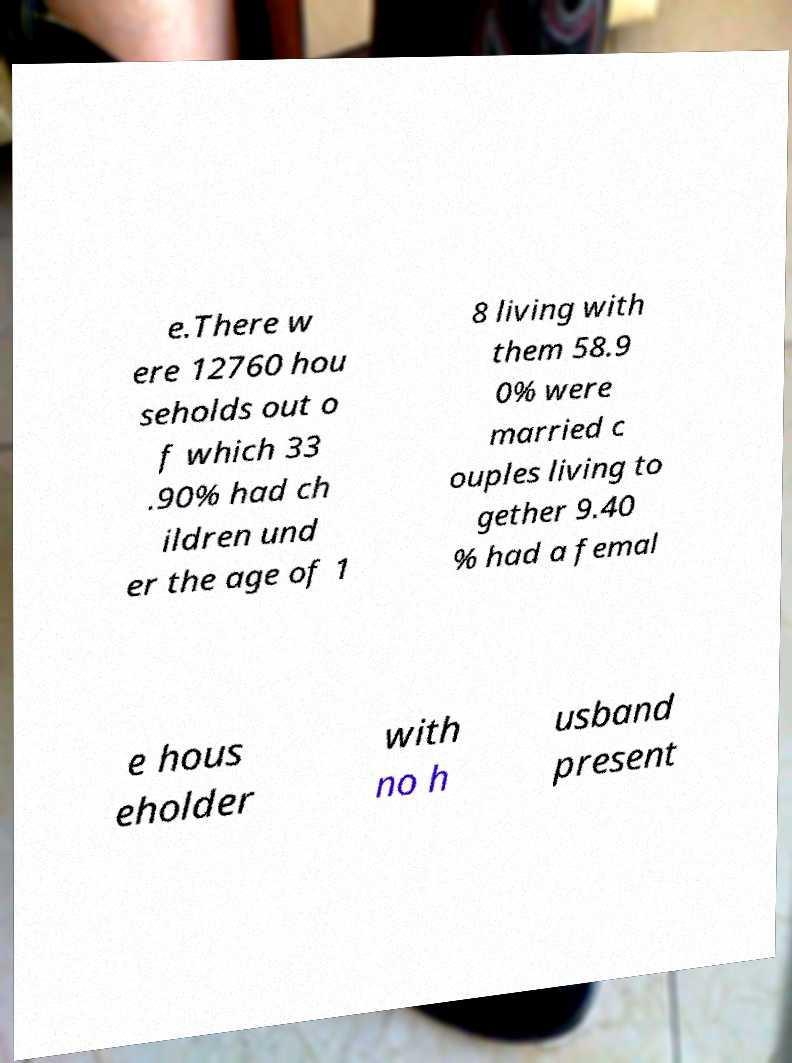Could you assist in decoding the text presented in this image and type it out clearly? e.There w ere 12760 hou seholds out o f which 33 .90% had ch ildren und er the age of 1 8 living with them 58.9 0% were married c ouples living to gether 9.40 % had a femal e hous eholder with no h usband present 